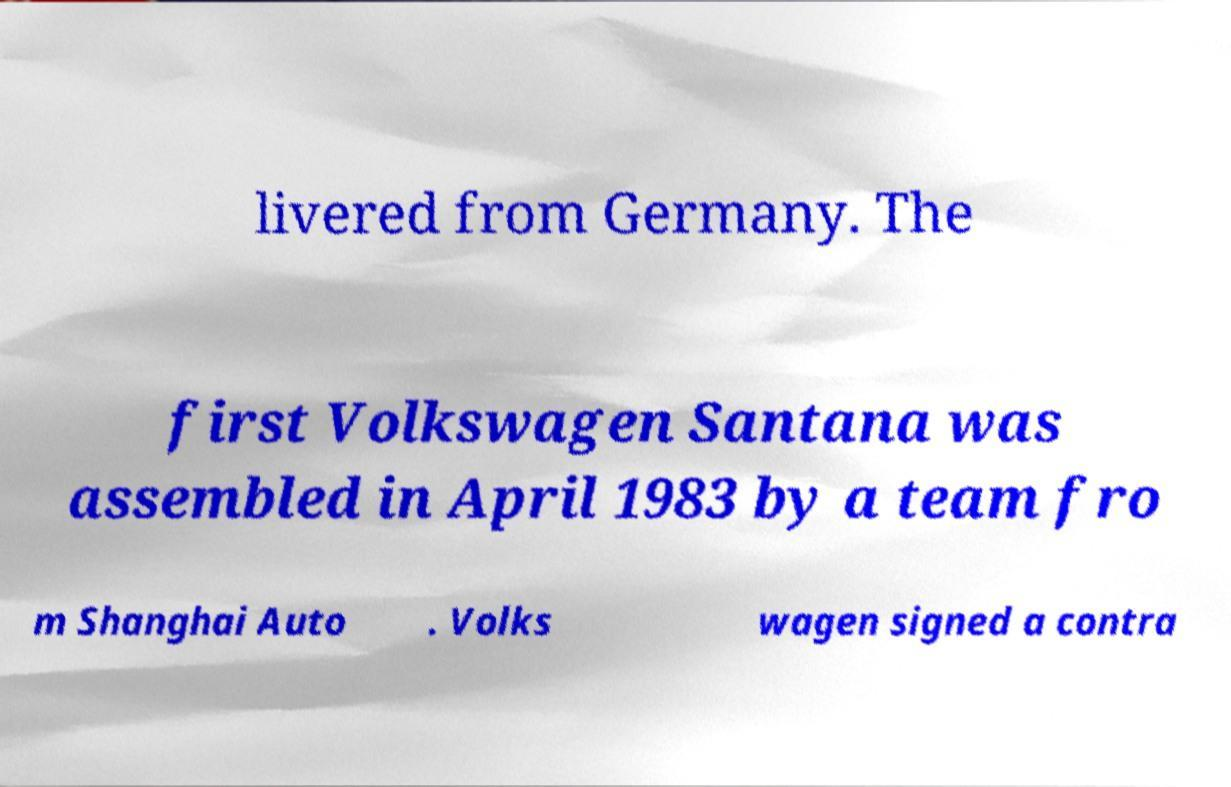There's text embedded in this image that I need extracted. Can you transcribe it verbatim? livered from Germany. The first Volkswagen Santana was assembled in April 1983 by a team fro m Shanghai Auto . Volks wagen signed a contra 